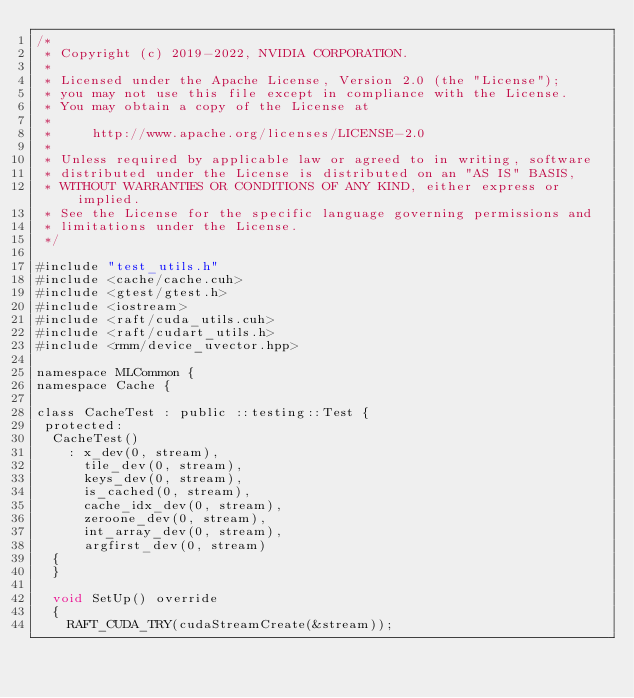<code> <loc_0><loc_0><loc_500><loc_500><_Cuda_>/*
 * Copyright (c) 2019-2022, NVIDIA CORPORATION.
 *
 * Licensed under the Apache License, Version 2.0 (the "License");
 * you may not use this file except in compliance with the License.
 * You may obtain a copy of the License at
 *
 *     http://www.apache.org/licenses/LICENSE-2.0
 *
 * Unless required by applicable law or agreed to in writing, software
 * distributed under the License is distributed on an "AS IS" BASIS,
 * WITHOUT WARRANTIES OR CONDITIONS OF ANY KIND, either express or implied.
 * See the License for the specific language governing permissions and
 * limitations under the License.
 */

#include "test_utils.h"
#include <cache/cache.cuh>
#include <gtest/gtest.h>
#include <iostream>
#include <raft/cuda_utils.cuh>
#include <raft/cudart_utils.h>
#include <rmm/device_uvector.hpp>

namespace MLCommon {
namespace Cache {

class CacheTest : public ::testing::Test {
 protected:
  CacheTest()
    : x_dev(0, stream),
      tile_dev(0, stream),
      keys_dev(0, stream),
      is_cached(0, stream),
      cache_idx_dev(0, stream),
      zeroone_dev(0, stream),
      int_array_dev(0, stream),
      argfirst_dev(0, stream)
  {
  }

  void SetUp() override
  {
    RAFT_CUDA_TRY(cudaStreamCreate(&stream));</code> 